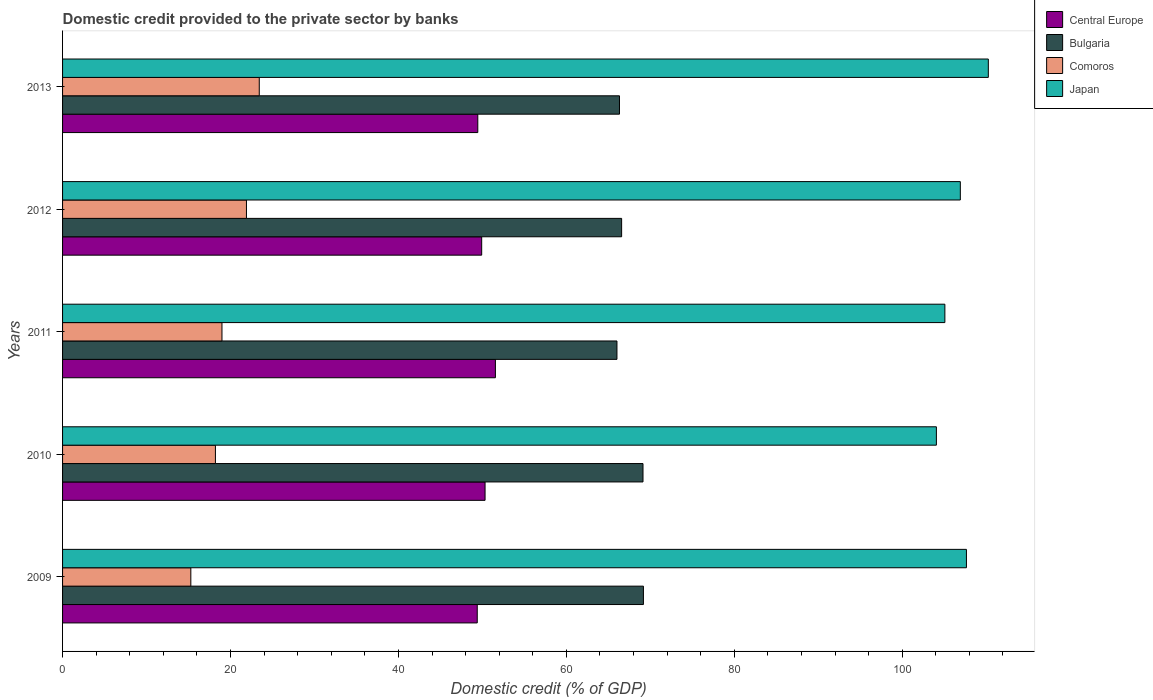How many different coloured bars are there?
Offer a terse response. 4. Are the number of bars per tick equal to the number of legend labels?
Your answer should be compact. Yes. What is the label of the 2nd group of bars from the top?
Give a very brief answer. 2012. What is the domestic credit provided to the private sector by banks in Japan in 2009?
Make the answer very short. 107.65. Across all years, what is the maximum domestic credit provided to the private sector by banks in Japan?
Your answer should be very brief. 110.26. Across all years, what is the minimum domestic credit provided to the private sector by banks in Central Europe?
Offer a terse response. 49.39. In which year was the domestic credit provided to the private sector by banks in Comoros maximum?
Give a very brief answer. 2013. What is the total domestic credit provided to the private sector by banks in Central Europe in the graph?
Offer a very short reply. 250.63. What is the difference between the domestic credit provided to the private sector by banks in Comoros in 2009 and that in 2013?
Provide a short and direct response. -8.15. What is the difference between the domestic credit provided to the private sector by banks in Comoros in 2009 and the domestic credit provided to the private sector by banks in Central Europe in 2012?
Your answer should be compact. -34.64. What is the average domestic credit provided to the private sector by banks in Central Europe per year?
Offer a very short reply. 50.13. In the year 2010, what is the difference between the domestic credit provided to the private sector by banks in Comoros and domestic credit provided to the private sector by banks in Central Europe?
Your answer should be compact. -32.11. In how many years, is the domestic credit provided to the private sector by banks in Bulgaria greater than 92 %?
Offer a very short reply. 0. What is the ratio of the domestic credit provided to the private sector by banks in Japan in 2009 to that in 2010?
Provide a succinct answer. 1.03. Is the domestic credit provided to the private sector by banks in Central Europe in 2012 less than that in 2013?
Provide a short and direct response. No. Is the difference between the domestic credit provided to the private sector by banks in Comoros in 2009 and 2013 greater than the difference between the domestic credit provided to the private sector by banks in Central Europe in 2009 and 2013?
Your answer should be very brief. No. What is the difference between the highest and the second highest domestic credit provided to the private sector by banks in Central Europe?
Provide a short and direct response. 1.23. What is the difference between the highest and the lowest domestic credit provided to the private sector by banks in Central Europe?
Keep it short and to the point. 2.16. Is the sum of the domestic credit provided to the private sector by banks in Comoros in 2009 and 2010 greater than the maximum domestic credit provided to the private sector by banks in Japan across all years?
Make the answer very short. No. What does the 1st bar from the top in 2009 represents?
Keep it short and to the point. Japan. What does the 1st bar from the bottom in 2010 represents?
Make the answer very short. Central Europe. Is it the case that in every year, the sum of the domestic credit provided to the private sector by banks in Central Europe and domestic credit provided to the private sector by banks in Japan is greater than the domestic credit provided to the private sector by banks in Bulgaria?
Your answer should be compact. Yes. Are all the bars in the graph horizontal?
Give a very brief answer. Yes. What is the difference between two consecutive major ticks on the X-axis?
Offer a terse response. 20. Are the values on the major ticks of X-axis written in scientific E-notation?
Your response must be concise. No. Does the graph contain any zero values?
Ensure brevity in your answer.  No. Does the graph contain grids?
Provide a succinct answer. No. Where does the legend appear in the graph?
Your response must be concise. Top right. How many legend labels are there?
Your response must be concise. 4. What is the title of the graph?
Keep it short and to the point. Domestic credit provided to the private sector by banks. Does "Thailand" appear as one of the legend labels in the graph?
Ensure brevity in your answer.  No. What is the label or title of the X-axis?
Give a very brief answer. Domestic credit (% of GDP). What is the label or title of the Y-axis?
Your response must be concise. Years. What is the Domestic credit (% of GDP) of Central Europe in 2009?
Offer a very short reply. 49.39. What is the Domestic credit (% of GDP) of Bulgaria in 2009?
Your response must be concise. 69.18. What is the Domestic credit (% of GDP) of Comoros in 2009?
Make the answer very short. 15.28. What is the Domestic credit (% of GDP) of Japan in 2009?
Ensure brevity in your answer.  107.65. What is the Domestic credit (% of GDP) of Central Europe in 2010?
Give a very brief answer. 50.32. What is the Domestic credit (% of GDP) of Bulgaria in 2010?
Provide a short and direct response. 69.13. What is the Domestic credit (% of GDP) of Comoros in 2010?
Give a very brief answer. 18.21. What is the Domestic credit (% of GDP) of Japan in 2010?
Make the answer very short. 104.07. What is the Domestic credit (% of GDP) in Central Europe in 2011?
Offer a very short reply. 51.55. What is the Domestic credit (% of GDP) in Bulgaria in 2011?
Offer a very short reply. 66.03. What is the Domestic credit (% of GDP) in Comoros in 2011?
Keep it short and to the point. 18.99. What is the Domestic credit (% of GDP) in Japan in 2011?
Provide a succinct answer. 105.08. What is the Domestic credit (% of GDP) in Central Europe in 2012?
Your answer should be very brief. 49.92. What is the Domestic credit (% of GDP) in Bulgaria in 2012?
Keep it short and to the point. 66.58. What is the Domestic credit (% of GDP) of Comoros in 2012?
Your answer should be very brief. 21.9. What is the Domestic credit (% of GDP) of Japan in 2012?
Your answer should be compact. 106.92. What is the Domestic credit (% of GDP) in Central Europe in 2013?
Offer a terse response. 49.45. What is the Domestic credit (% of GDP) in Bulgaria in 2013?
Give a very brief answer. 66.33. What is the Domestic credit (% of GDP) of Comoros in 2013?
Your answer should be very brief. 23.43. What is the Domestic credit (% of GDP) in Japan in 2013?
Give a very brief answer. 110.26. Across all years, what is the maximum Domestic credit (% of GDP) in Central Europe?
Give a very brief answer. 51.55. Across all years, what is the maximum Domestic credit (% of GDP) of Bulgaria?
Ensure brevity in your answer.  69.18. Across all years, what is the maximum Domestic credit (% of GDP) of Comoros?
Your answer should be compact. 23.43. Across all years, what is the maximum Domestic credit (% of GDP) of Japan?
Your response must be concise. 110.26. Across all years, what is the minimum Domestic credit (% of GDP) in Central Europe?
Keep it short and to the point. 49.39. Across all years, what is the minimum Domestic credit (% of GDP) in Bulgaria?
Keep it short and to the point. 66.03. Across all years, what is the minimum Domestic credit (% of GDP) in Comoros?
Offer a terse response. 15.28. Across all years, what is the minimum Domestic credit (% of GDP) in Japan?
Your answer should be very brief. 104.07. What is the total Domestic credit (% of GDP) in Central Europe in the graph?
Give a very brief answer. 250.63. What is the total Domestic credit (% of GDP) in Bulgaria in the graph?
Make the answer very short. 337.25. What is the total Domestic credit (% of GDP) of Comoros in the graph?
Ensure brevity in your answer.  97.8. What is the total Domestic credit (% of GDP) in Japan in the graph?
Provide a short and direct response. 533.99. What is the difference between the Domestic credit (% of GDP) of Central Europe in 2009 and that in 2010?
Make the answer very short. -0.93. What is the difference between the Domestic credit (% of GDP) of Bulgaria in 2009 and that in 2010?
Your answer should be very brief. 0.05. What is the difference between the Domestic credit (% of GDP) in Comoros in 2009 and that in 2010?
Keep it short and to the point. -2.93. What is the difference between the Domestic credit (% of GDP) of Japan in 2009 and that in 2010?
Ensure brevity in your answer.  3.58. What is the difference between the Domestic credit (% of GDP) of Central Europe in 2009 and that in 2011?
Ensure brevity in your answer.  -2.16. What is the difference between the Domestic credit (% of GDP) of Bulgaria in 2009 and that in 2011?
Offer a terse response. 3.15. What is the difference between the Domestic credit (% of GDP) in Comoros in 2009 and that in 2011?
Provide a succinct answer. -3.71. What is the difference between the Domestic credit (% of GDP) in Japan in 2009 and that in 2011?
Offer a very short reply. 2.57. What is the difference between the Domestic credit (% of GDP) of Central Europe in 2009 and that in 2012?
Keep it short and to the point. -0.53. What is the difference between the Domestic credit (% of GDP) of Bulgaria in 2009 and that in 2012?
Your answer should be compact. 2.6. What is the difference between the Domestic credit (% of GDP) in Comoros in 2009 and that in 2012?
Make the answer very short. -6.62. What is the difference between the Domestic credit (% of GDP) in Japan in 2009 and that in 2012?
Your response must be concise. 0.73. What is the difference between the Domestic credit (% of GDP) in Central Europe in 2009 and that in 2013?
Offer a very short reply. -0.07. What is the difference between the Domestic credit (% of GDP) in Bulgaria in 2009 and that in 2013?
Make the answer very short. 2.85. What is the difference between the Domestic credit (% of GDP) of Comoros in 2009 and that in 2013?
Your answer should be compact. -8.15. What is the difference between the Domestic credit (% of GDP) of Japan in 2009 and that in 2013?
Offer a terse response. -2.61. What is the difference between the Domestic credit (% of GDP) in Central Europe in 2010 and that in 2011?
Offer a terse response. -1.23. What is the difference between the Domestic credit (% of GDP) of Bulgaria in 2010 and that in 2011?
Offer a very short reply. 3.1. What is the difference between the Domestic credit (% of GDP) of Comoros in 2010 and that in 2011?
Provide a short and direct response. -0.78. What is the difference between the Domestic credit (% of GDP) of Japan in 2010 and that in 2011?
Make the answer very short. -1.01. What is the difference between the Domestic credit (% of GDP) in Central Europe in 2010 and that in 2012?
Make the answer very short. 0.4. What is the difference between the Domestic credit (% of GDP) of Bulgaria in 2010 and that in 2012?
Your answer should be compact. 2.55. What is the difference between the Domestic credit (% of GDP) in Comoros in 2010 and that in 2012?
Your answer should be compact. -3.7. What is the difference between the Domestic credit (% of GDP) in Japan in 2010 and that in 2012?
Ensure brevity in your answer.  -2.85. What is the difference between the Domestic credit (% of GDP) of Central Europe in 2010 and that in 2013?
Provide a short and direct response. 0.87. What is the difference between the Domestic credit (% of GDP) of Bulgaria in 2010 and that in 2013?
Provide a succinct answer. 2.8. What is the difference between the Domestic credit (% of GDP) in Comoros in 2010 and that in 2013?
Ensure brevity in your answer.  -5.22. What is the difference between the Domestic credit (% of GDP) of Japan in 2010 and that in 2013?
Make the answer very short. -6.19. What is the difference between the Domestic credit (% of GDP) of Central Europe in 2011 and that in 2012?
Ensure brevity in your answer.  1.63. What is the difference between the Domestic credit (% of GDP) of Bulgaria in 2011 and that in 2012?
Offer a very short reply. -0.56. What is the difference between the Domestic credit (% of GDP) of Comoros in 2011 and that in 2012?
Your response must be concise. -2.91. What is the difference between the Domestic credit (% of GDP) of Japan in 2011 and that in 2012?
Offer a very short reply. -1.84. What is the difference between the Domestic credit (% of GDP) in Central Europe in 2011 and that in 2013?
Ensure brevity in your answer.  2.1. What is the difference between the Domestic credit (% of GDP) in Bulgaria in 2011 and that in 2013?
Keep it short and to the point. -0.3. What is the difference between the Domestic credit (% of GDP) of Comoros in 2011 and that in 2013?
Your answer should be compact. -4.44. What is the difference between the Domestic credit (% of GDP) in Japan in 2011 and that in 2013?
Your response must be concise. -5.17. What is the difference between the Domestic credit (% of GDP) in Central Europe in 2012 and that in 2013?
Make the answer very short. 0.46. What is the difference between the Domestic credit (% of GDP) of Bulgaria in 2012 and that in 2013?
Make the answer very short. 0.25. What is the difference between the Domestic credit (% of GDP) of Comoros in 2012 and that in 2013?
Make the answer very short. -1.53. What is the difference between the Domestic credit (% of GDP) of Japan in 2012 and that in 2013?
Ensure brevity in your answer.  -3.33. What is the difference between the Domestic credit (% of GDP) in Central Europe in 2009 and the Domestic credit (% of GDP) in Bulgaria in 2010?
Offer a very short reply. -19.74. What is the difference between the Domestic credit (% of GDP) of Central Europe in 2009 and the Domestic credit (% of GDP) of Comoros in 2010?
Offer a very short reply. 31.18. What is the difference between the Domestic credit (% of GDP) of Central Europe in 2009 and the Domestic credit (% of GDP) of Japan in 2010?
Your answer should be compact. -54.68. What is the difference between the Domestic credit (% of GDP) in Bulgaria in 2009 and the Domestic credit (% of GDP) in Comoros in 2010?
Offer a very short reply. 50.97. What is the difference between the Domestic credit (% of GDP) in Bulgaria in 2009 and the Domestic credit (% of GDP) in Japan in 2010?
Give a very brief answer. -34.89. What is the difference between the Domestic credit (% of GDP) of Comoros in 2009 and the Domestic credit (% of GDP) of Japan in 2010?
Make the answer very short. -88.8. What is the difference between the Domestic credit (% of GDP) of Central Europe in 2009 and the Domestic credit (% of GDP) of Bulgaria in 2011?
Your answer should be compact. -16.64. What is the difference between the Domestic credit (% of GDP) of Central Europe in 2009 and the Domestic credit (% of GDP) of Comoros in 2011?
Ensure brevity in your answer.  30.4. What is the difference between the Domestic credit (% of GDP) of Central Europe in 2009 and the Domestic credit (% of GDP) of Japan in 2011?
Keep it short and to the point. -55.69. What is the difference between the Domestic credit (% of GDP) in Bulgaria in 2009 and the Domestic credit (% of GDP) in Comoros in 2011?
Offer a very short reply. 50.19. What is the difference between the Domestic credit (% of GDP) in Bulgaria in 2009 and the Domestic credit (% of GDP) in Japan in 2011?
Offer a terse response. -35.9. What is the difference between the Domestic credit (% of GDP) in Comoros in 2009 and the Domestic credit (% of GDP) in Japan in 2011?
Offer a terse response. -89.81. What is the difference between the Domestic credit (% of GDP) in Central Europe in 2009 and the Domestic credit (% of GDP) in Bulgaria in 2012?
Provide a short and direct response. -17.2. What is the difference between the Domestic credit (% of GDP) in Central Europe in 2009 and the Domestic credit (% of GDP) in Comoros in 2012?
Offer a terse response. 27.49. What is the difference between the Domestic credit (% of GDP) of Central Europe in 2009 and the Domestic credit (% of GDP) of Japan in 2012?
Your answer should be compact. -57.53. What is the difference between the Domestic credit (% of GDP) in Bulgaria in 2009 and the Domestic credit (% of GDP) in Comoros in 2012?
Your answer should be very brief. 47.28. What is the difference between the Domestic credit (% of GDP) of Bulgaria in 2009 and the Domestic credit (% of GDP) of Japan in 2012?
Offer a terse response. -37.74. What is the difference between the Domestic credit (% of GDP) in Comoros in 2009 and the Domestic credit (% of GDP) in Japan in 2012?
Offer a terse response. -91.65. What is the difference between the Domestic credit (% of GDP) in Central Europe in 2009 and the Domestic credit (% of GDP) in Bulgaria in 2013?
Offer a very short reply. -16.94. What is the difference between the Domestic credit (% of GDP) of Central Europe in 2009 and the Domestic credit (% of GDP) of Comoros in 2013?
Ensure brevity in your answer.  25.96. What is the difference between the Domestic credit (% of GDP) in Central Europe in 2009 and the Domestic credit (% of GDP) in Japan in 2013?
Offer a terse response. -60.87. What is the difference between the Domestic credit (% of GDP) of Bulgaria in 2009 and the Domestic credit (% of GDP) of Comoros in 2013?
Offer a very short reply. 45.75. What is the difference between the Domestic credit (% of GDP) in Bulgaria in 2009 and the Domestic credit (% of GDP) in Japan in 2013?
Ensure brevity in your answer.  -41.08. What is the difference between the Domestic credit (% of GDP) in Comoros in 2009 and the Domestic credit (% of GDP) in Japan in 2013?
Your response must be concise. -94.98. What is the difference between the Domestic credit (% of GDP) in Central Europe in 2010 and the Domestic credit (% of GDP) in Bulgaria in 2011?
Provide a succinct answer. -15.71. What is the difference between the Domestic credit (% of GDP) in Central Europe in 2010 and the Domestic credit (% of GDP) in Comoros in 2011?
Provide a succinct answer. 31.33. What is the difference between the Domestic credit (% of GDP) of Central Europe in 2010 and the Domestic credit (% of GDP) of Japan in 2011?
Your answer should be compact. -54.76. What is the difference between the Domestic credit (% of GDP) in Bulgaria in 2010 and the Domestic credit (% of GDP) in Comoros in 2011?
Provide a short and direct response. 50.14. What is the difference between the Domestic credit (% of GDP) of Bulgaria in 2010 and the Domestic credit (% of GDP) of Japan in 2011?
Provide a succinct answer. -35.95. What is the difference between the Domestic credit (% of GDP) of Comoros in 2010 and the Domestic credit (% of GDP) of Japan in 2011?
Offer a terse response. -86.88. What is the difference between the Domestic credit (% of GDP) of Central Europe in 2010 and the Domestic credit (% of GDP) of Bulgaria in 2012?
Your answer should be compact. -16.26. What is the difference between the Domestic credit (% of GDP) of Central Europe in 2010 and the Domestic credit (% of GDP) of Comoros in 2012?
Provide a short and direct response. 28.42. What is the difference between the Domestic credit (% of GDP) of Central Europe in 2010 and the Domestic credit (% of GDP) of Japan in 2012?
Make the answer very short. -56.6. What is the difference between the Domestic credit (% of GDP) of Bulgaria in 2010 and the Domestic credit (% of GDP) of Comoros in 2012?
Provide a short and direct response. 47.23. What is the difference between the Domestic credit (% of GDP) of Bulgaria in 2010 and the Domestic credit (% of GDP) of Japan in 2012?
Keep it short and to the point. -37.79. What is the difference between the Domestic credit (% of GDP) in Comoros in 2010 and the Domestic credit (% of GDP) in Japan in 2012?
Your answer should be very brief. -88.72. What is the difference between the Domestic credit (% of GDP) in Central Europe in 2010 and the Domestic credit (% of GDP) in Bulgaria in 2013?
Provide a short and direct response. -16.01. What is the difference between the Domestic credit (% of GDP) of Central Europe in 2010 and the Domestic credit (% of GDP) of Comoros in 2013?
Offer a very short reply. 26.89. What is the difference between the Domestic credit (% of GDP) in Central Europe in 2010 and the Domestic credit (% of GDP) in Japan in 2013?
Your response must be concise. -59.94. What is the difference between the Domestic credit (% of GDP) in Bulgaria in 2010 and the Domestic credit (% of GDP) in Comoros in 2013?
Offer a very short reply. 45.7. What is the difference between the Domestic credit (% of GDP) in Bulgaria in 2010 and the Domestic credit (% of GDP) in Japan in 2013?
Offer a very short reply. -41.13. What is the difference between the Domestic credit (% of GDP) of Comoros in 2010 and the Domestic credit (% of GDP) of Japan in 2013?
Provide a short and direct response. -92.05. What is the difference between the Domestic credit (% of GDP) in Central Europe in 2011 and the Domestic credit (% of GDP) in Bulgaria in 2012?
Make the answer very short. -15.03. What is the difference between the Domestic credit (% of GDP) of Central Europe in 2011 and the Domestic credit (% of GDP) of Comoros in 2012?
Your answer should be very brief. 29.65. What is the difference between the Domestic credit (% of GDP) in Central Europe in 2011 and the Domestic credit (% of GDP) in Japan in 2012?
Your answer should be very brief. -55.37. What is the difference between the Domestic credit (% of GDP) in Bulgaria in 2011 and the Domestic credit (% of GDP) in Comoros in 2012?
Provide a short and direct response. 44.13. What is the difference between the Domestic credit (% of GDP) of Bulgaria in 2011 and the Domestic credit (% of GDP) of Japan in 2012?
Your response must be concise. -40.9. What is the difference between the Domestic credit (% of GDP) of Comoros in 2011 and the Domestic credit (% of GDP) of Japan in 2012?
Make the answer very short. -87.94. What is the difference between the Domestic credit (% of GDP) in Central Europe in 2011 and the Domestic credit (% of GDP) in Bulgaria in 2013?
Your response must be concise. -14.78. What is the difference between the Domestic credit (% of GDP) of Central Europe in 2011 and the Domestic credit (% of GDP) of Comoros in 2013?
Your response must be concise. 28.12. What is the difference between the Domestic credit (% of GDP) of Central Europe in 2011 and the Domestic credit (% of GDP) of Japan in 2013?
Keep it short and to the point. -58.71. What is the difference between the Domestic credit (% of GDP) in Bulgaria in 2011 and the Domestic credit (% of GDP) in Comoros in 2013?
Make the answer very short. 42.6. What is the difference between the Domestic credit (% of GDP) in Bulgaria in 2011 and the Domestic credit (% of GDP) in Japan in 2013?
Your response must be concise. -44.23. What is the difference between the Domestic credit (% of GDP) of Comoros in 2011 and the Domestic credit (% of GDP) of Japan in 2013?
Your answer should be compact. -91.27. What is the difference between the Domestic credit (% of GDP) of Central Europe in 2012 and the Domestic credit (% of GDP) of Bulgaria in 2013?
Your answer should be compact. -16.41. What is the difference between the Domestic credit (% of GDP) of Central Europe in 2012 and the Domestic credit (% of GDP) of Comoros in 2013?
Keep it short and to the point. 26.49. What is the difference between the Domestic credit (% of GDP) of Central Europe in 2012 and the Domestic credit (% of GDP) of Japan in 2013?
Provide a short and direct response. -60.34. What is the difference between the Domestic credit (% of GDP) in Bulgaria in 2012 and the Domestic credit (% of GDP) in Comoros in 2013?
Your response must be concise. 43.16. What is the difference between the Domestic credit (% of GDP) in Bulgaria in 2012 and the Domestic credit (% of GDP) in Japan in 2013?
Make the answer very short. -43.67. What is the difference between the Domestic credit (% of GDP) in Comoros in 2012 and the Domestic credit (% of GDP) in Japan in 2013?
Your answer should be very brief. -88.36. What is the average Domestic credit (% of GDP) of Central Europe per year?
Offer a very short reply. 50.13. What is the average Domestic credit (% of GDP) of Bulgaria per year?
Keep it short and to the point. 67.45. What is the average Domestic credit (% of GDP) of Comoros per year?
Provide a short and direct response. 19.56. What is the average Domestic credit (% of GDP) in Japan per year?
Offer a terse response. 106.8. In the year 2009, what is the difference between the Domestic credit (% of GDP) in Central Europe and Domestic credit (% of GDP) in Bulgaria?
Offer a terse response. -19.79. In the year 2009, what is the difference between the Domestic credit (% of GDP) in Central Europe and Domestic credit (% of GDP) in Comoros?
Provide a short and direct response. 34.11. In the year 2009, what is the difference between the Domestic credit (% of GDP) in Central Europe and Domestic credit (% of GDP) in Japan?
Give a very brief answer. -58.26. In the year 2009, what is the difference between the Domestic credit (% of GDP) in Bulgaria and Domestic credit (% of GDP) in Comoros?
Ensure brevity in your answer.  53.9. In the year 2009, what is the difference between the Domestic credit (% of GDP) in Bulgaria and Domestic credit (% of GDP) in Japan?
Offer a terse response. -38.47. In the year 2009, what is the difference between the Domestic credit (% of GDP) in Comoros and Domestic credit (% of GDP) in Japan?
Make the answer very short. -92.37. In the year 2010, what is the difference between the Domestic credit (% of GDP) of Central Europe and Domestic credit (% of GDP) of Bulgaria?
Offer a terse response. -18.81. In the year 2010, what is the difference between the Domestic credit (% of GDP) in Central Europe and Domestic credit (% of GDP) in Comoros?
Give a very brief answer. 32.11. In the year 2010, what is the difference between the Domestic credit (% of GDP) in Central Europe and Domestic credit (% of GDP) in Japan?
Give a very brief answer. -53.75. In the year 2010, what is the difference between the Domestic credit (% of GDP) of Bulgaria and Domestic credit (% of GDP) of Comoros?
Your response must be concise. 50.92. In the year 2010, what is the difference between the Domestic credit (% of GDP) of Bulgaria and Domestic credit (% of GDP) of Japan?
Your response must be concise. -34.94. In the year 2010, what is the difference between the Domestic credit (% of GDP) of Comoros and Domestic credit (% of GDP) of Japan?
Your answer should be compact. -85.87. In the year 2011, what is the difference between the Domestic credit (% of GDP) in Central Europe and Domestic credit (% of GDP) in Bulgaria?
Give a very brief answer. -14.48. In the year 2011, what is the difference between the Domestic credit (% of GDP) of Central Europe and Domestic credit (% of GDP) of Comoros?
Provide a succinct answer. 32.56. In the year 2011, what is the difference between the Domestic credit (% of GDP) in Central Europe and Domestic credit (% of GDP) in Japan?
Keep it short and to the point. -53.53. In the year 2011, what is the difference between the Domestic credit (% of GDP) in Bulgaria and Domestic credit (% of GDP) in Comoros?
Offer a very short reply. 47.04. In the year 2011, what is the difference between the Domestic credit (% of GDP) in Bulgaria and Domestic credit (% of GDP) in Japan?
Your answer should be very brief. -39.06. In the year 2011, what is the difference between the Domestic credit (% of GDP) of Comoros and Domestic credit (% of GDP) of Japan?
Your answer should be very brief. -86.1. In the year 2012, what is the difference between the Domestic credit (% of GDP) in Central Europe and Domestic credit (% of GDP) in Bulgaria?
Provide a succinct answer. -16.67. In the year 2012, what is the difference between the Domestic credit (% of GDP) of Central Europe and Domestic credit (% of GDP) of Comoros?
Keep it short and to the point. 28.02. In the year 2012, what is the difference between the Domestic credit (% of GDP) in Central Europe and Domestic credit (% of GDP) in Japan?
Offer a very short reply. -57.01. In the year 2012, what is the difference between the Domestic credit (% of GDP) in Bulgaria and Domestic credit (% of GDP) in Comoros?
Give a very brief answer. 44.68. In the year 2012, what is the difference between the Domestic credit (% of GDP) in Bulgaria and Domestic credit (% of GDP) in Japan?
Provide a succinct answer. -40.34. In the year 2012, what is the difference between the Domestic credit (% of GDP) of Comoros and Domestic credit (% of GDP) of Japan?
Your answer should be very brief. -85.02. In the year 2013, what is the difference between the Domestic credit (% of GDP) in Central Europe and Domestic credit (% of GDP) in Bulgaria?
Your answer should be very brief. -16.88. In the year 2013, what is the difference between the Domestic credit (% of GDP) in Central Europe and Domestic credit (% of GDP) in Comoros?
Offer a very short reply. 26.03. In the year 2013, what is the difference between the Domestic credit (% of GDP) in Central Europe and Domestic credit (% of GDP) in Japan?
Provide a short and direct response. -60.8. In the year 2013, what is the difference between the Domestic credit (% of GDP) in Bulgaria and Domestic credit (% of GDP) in Comoros?
Provide a short and direct response. 42.9. In the year 2013, what is the difference between the Domestic credit (% of GDP) in Bulgaria and Domestic credit (% of GDP) in Japan?
Keep it short and to the point. -43.93. In the year 2013, what is the difference between the Domestic credit (% of GDP) of Comoros and Domestic credit (% of GDP) of Japan?
Provide a short and direct response. -86.83. What is the ratio of the Domestic credit (% of GDP) in Central Europe in 2009 to that in 2010?
Offer a terse response. 0.98. What is the ratio of the Domestic credit (% of GDP) in Comoros in 2009 to that in 2010?
Your answer should be compact. 0.84. What is the ratio of the Domestic credit (% of GDP) of Japan in 2009 to that in 2010?
Make the answer very short. 1.03. What is the ratio of the Domestic credit (% of GDP) in Central Europe in 2009 to that in 2011?
Offer a terse response. 0.96. What is the ratio of the Domestic credit (% of GDP) of Bulgaria in 2009 to that in 2011?
Keep it short and to the point. 1.05. What is the ratio of the Domestic credit (% of GDP) of Comoros in 2009 to that in 2011?
Your answer should be very brief. 0.8. What is the ratio of the Domestic credit (% of GDP) in Japan in 2009 to that in 2011?
Offer a terse response. 1.02. What is the ratio of the Domestic credit (% of GDP) in Central Europe in 2009 to that in 2012?
Give a very brief answer. 0.99. What is the ratio of the Domestic credit (% of GDP) of Bulgaria in 2009 to that in 2012?
Ensure brevity in your answer.  1.04. What is the ratio of the Domestic credit (% of GDP) in Comoros in 2009 to that in 2012?
Your answer should be compact. 0.7. What is the ratio of the Domestic credit (% of GDP) in Japan in 2009 to that in 2012?
Provide a short and direct response. 1.01. What is the ratio of the Domestic credit (% of GDP) of Central Europe in 2009 to that in 2013?
Offer a terse response. 1. What is the ratio of the Domestic credit (% of GDP) in Bulgaria in 2009 to that in 2013?
Provide a succinct answer. 1.04. What is the ratio of the Domestic credit (% of GDP) in Comoros in 2009 to that in 2013?
Your answer should be compact. 0.65. What is the ratio of the Domestic credit (% of GDP) of Japan in 2009 to that in 2013?
Provide a succinct answer. 0.98. What is the ratio of the Domestic credit (% of GDP) of Central Europe in 2010 to that in 2011?
Provide a short and direct response. 0.98. What is the ratio of the Domestic credit (% of GDP) in Bulgaria in 2010 to that in 2011?
Your answer should be very brief. 1.05. What is the ratio of the Domestic credit (% of GDP) in Comoros in 2010 to that in 2011?
Your answer should be very brief. 0.96. What is the ratio of the Domestic credit (% of GDP) of Bulgaria in 2010 to that in 2012?
Your answer should be very brief. 1.04. What is the ratio of the Domestic credit (% of GDP) of Comoros in 2010 to that in 2012?
Offer a very short reply. 0.83. What is the ratio of the Domestic credit (% of GDP) of Japan in 2010 to that in 2012?
Provide a succinct answer. 0.97. What is the ratio of the Domestic credit (% of GDP) of Central Europe in 2010 to that in 2013?
Provide a short and direct response. 1.02. What is the ratio of the Domestic credit (% of GDP) of Bulgaria in 2010 to that in 2013?
Make the answer very short. 1.04. What is the ratio of the Domestic credit (% of GDP) of Comoros in 2010 to that in 2013?
Ensure brevity in your answer.  0.78. What is the ratio of the Domestic credit (% of GDP) of Japan in 2010 to that in 2013?
Give a very brief answer. 0.94. What is the ratio of the Domestic credit (% of GDP) in Central Europe in 2011 to that in 2012?
Provide a succinct answer. 1.03. What is the ratio of the Domestic credit (% of GDP) of Comoros in 2011 to that in 2012?
Make the answer very short. 0.87. What is the ratio of the Domestic credit (% of GDP) in Japan in 2011 to that in 2012?
Your answer should be very brief. 0.98. What is the ratio of the Domestic credit (% of GDP) of Central Europe in 2011 to that in 2013?
Give a very brief answer. 1.04. What is the ratio of the Domestic credit (% of GDP) in Bulgaria in 2011 to that in 2013?
Your response must be concise. 1. What is the ratio of the Domestic credit (% of GDP) in Comoros in 2011 to that in 2013?
Offer a terse response. 0.81. What is the ratio of the Domestic credit (% of GDP) in Japan in 2011 to that in 2013?
Offer a terse response. 0.95. What is the ratio of the Domestic credit (% of GDP) of Central Europe in 2012 to that in 2013?
Your answer should be very brief. 1.01. What is the ratio of the Domestic credit (% of GDP) in Bulgaria in 2012 to that in 2013?
Offer a very short reply. 1. What is the ratio of the Domestic credit (% of GDP) in Comoros in 2012 to that in 2013?
Your response must be concise. 0.93. What is the ratio of the Domestic credit (% of GDP) in Japan in 2012 to that in 2013?
Give a very brief answer. 0.97. What is the difference between the highest and the second highest Domestic credit (% of GDP) of Central Europe?
Offer a very short reply. 1.23. What is the difference between the highest and the second highest Domestic credit (% of GDP) in Bulgaria?
Your answer should be compact. 0.05. What is the difference between the highest and the second highest Domestic credit (% of GDP) in Comoros?
Make the answer very short. 1.53. What is the difference between the highest and the second highest Domestic credit (% of GDP) in Japan?
Offer a very short reply. 2.61. What is the difference between the highest and the lowest Domestic credit (% of GDP) of Central Europe?
Provide a succinct answer. 2.16. What is the difference between the highest and the lowest Domestic credit (% of GDP) in Bulgaria?
Your answer should be compact. 3.15. What is the difference between the highest and the lowest Domestic credit (% of GDP) of Comoros?
Provide a succinct answer. 8.15. What is the difference between the highest and the lowest Domestic credit (% of GDP) in Japan?
Provide a short and direct response. 6.19. 